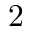Convert formula to latex. <formula><loc_0><loc_0><loc_500><loc_500>2</formula> 